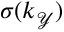<formula> <loc_0><loc_0><loc_500><loc_500>\sigma ( k _ { \mathcal { Y } } )</formula> 